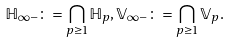<formula> <loc_0><loc_0><loc_500><loc_500>\mathbb { H } _ { \infty - } \colon = \bigcap _ { p \geq 1 } \mathbb { H } _ { p } , \mathbb { V } _ { \infty - } \colon = \bigcap _ { p \geq 1 } \mathbb { V } _ { p } .</formula> 